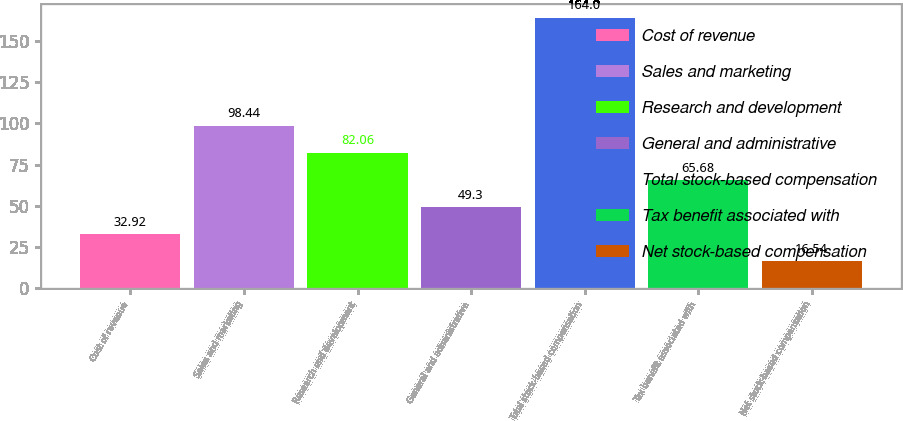<chart> <loc_0><loc_0><loc_500><loc_500><bar_chart><fcel>Cost of revenue<fcel>Sales and marketing<fcel>Research and development<fcel>General and administrative<fcel>Total stock-based compensation<fcel>Tax benefit associated with<fcel>Net stock-based compensation<nl><fcel>32.92<fcel>98.44<fcel>82.06<fcel>49.3<fcel>164<fcel>65.68<fcel>16.54<nl></chart> 